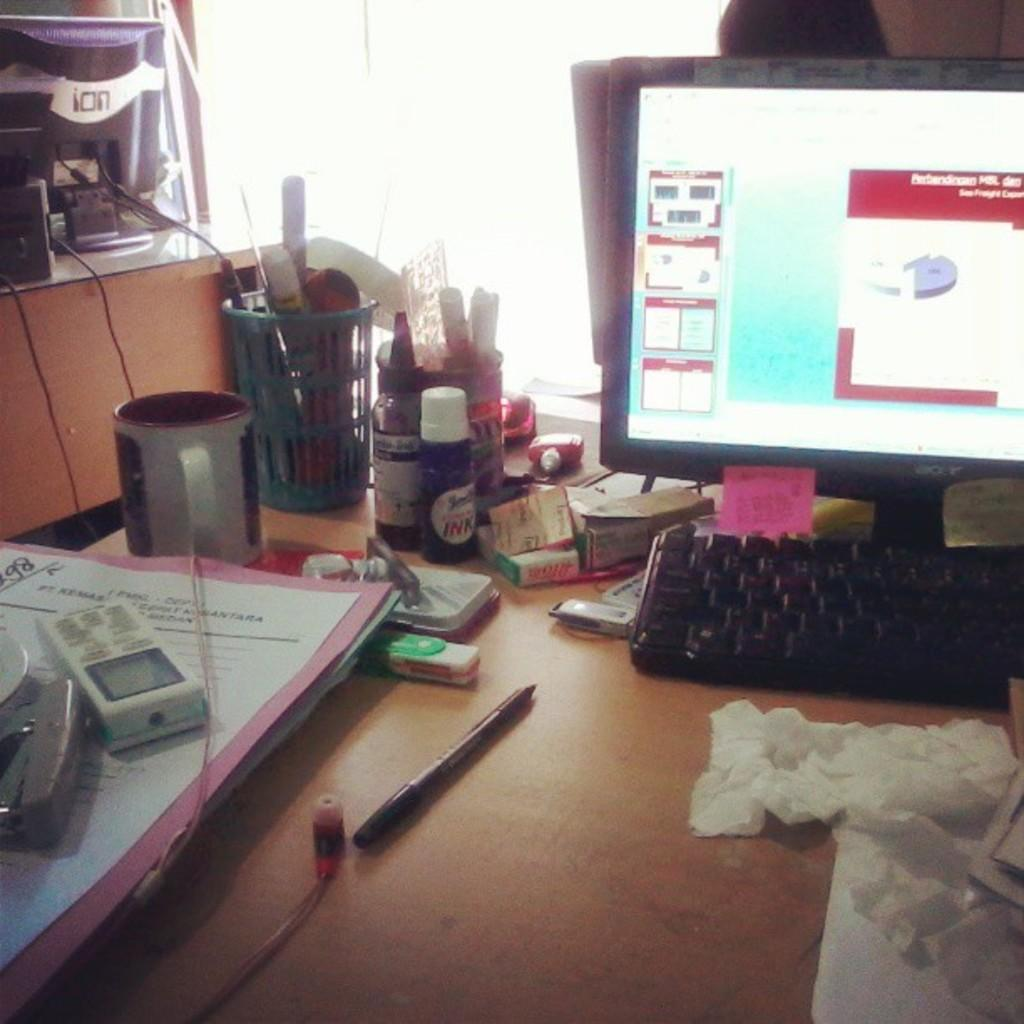What piece of furniture is present in the image? There is a table in the image. What electronic device is placed on the table? A monitor is placed on the table. What is used for typing on the computer in the image? A keyboard is placed on the table. What other items can be seen on the table? There are accessories on the table. What can be seen in the background of the image? There is a window in the background of the image. How does the person in the image adjust the position of the monitor to help them see better? There is no person present in the image, so it is not possible to determine how they would adjust the position of the monitor to help them see better. 